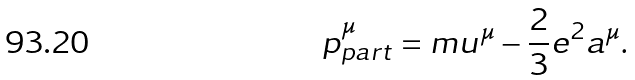<formula> <loc_0><loc_0><loc_500><loc_500>p _ { p a r t } ^ { \mu } = m u ^ { \mu } - \frac { 2 } { 3 } e ^ { 2 } a ^ { \mu } .</formula> 